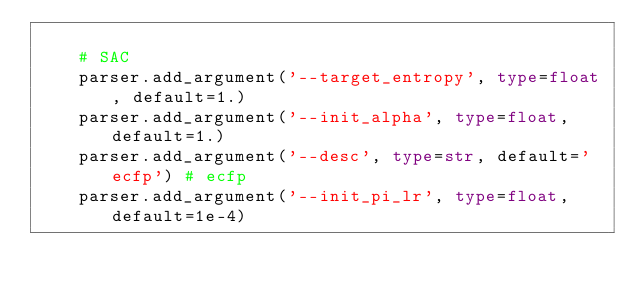Convert code to text. <code><loc_0><loc_0><loc_500><loc_500><_Python_>
    # SAC
    parser.add_argument('--target_entropy', type=float, default=1.)
    parser.add_argument('--init_alpha', type=float, default=1.)
    parser.add_argument('--desc', type=str, default='ecfp') # ecfp
    parser.add_argument('--init_pi_lr', type=float, default=1e-4)</code> 